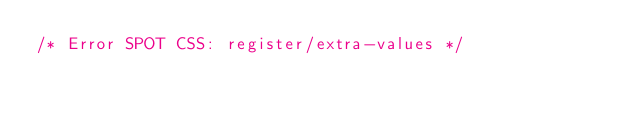Convert code to text. <code><loc_0><loc_0><loc_500><loc_500><_CSS_>/* Error SPOT CSS: register/extra-values */</code> 